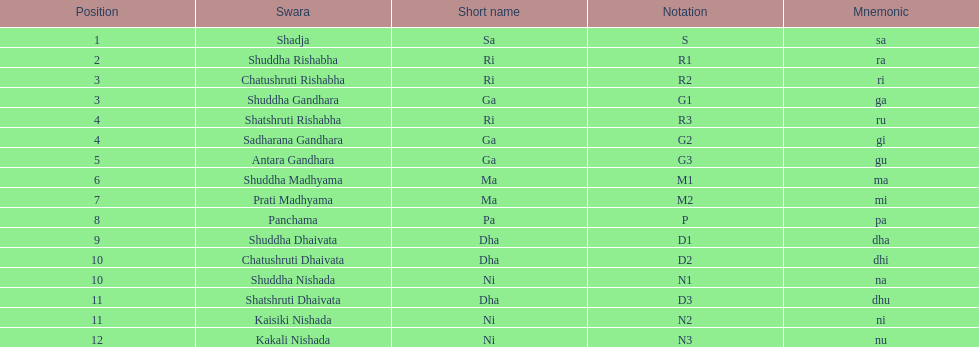How many swaras are without dhaivata in their name? 13. 